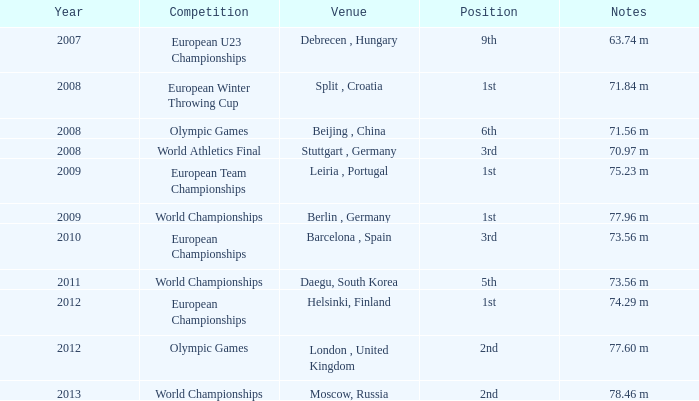In which year does the 9th spot occur? 2007.0. 